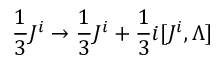Convert formula to latex. <formula><loc_0><loc_0><loc_500><loc_500>{ \frac { 1 } { 3 } } J ^ { i } \to { \frac { 1 } { 3 } } J ^ { i } + { \frac { 1 } { 3 } } i [ J ^ { i } , \Lambda ]</formula> 